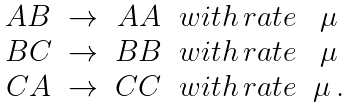Convert formula to latex. <formula><loc_0><loc_0><loc_500><loc_500>\begin{array} { c c c c c } A B & \rightarrow & A A & w i t h \, r a t e & \mu \\ B C & \rightarrow & B B & w i t h \, r a t e & \mu \\ C A & \rightarrow & C C & w i t h \, r a t e & \mu \, . \end{array}</formula> 